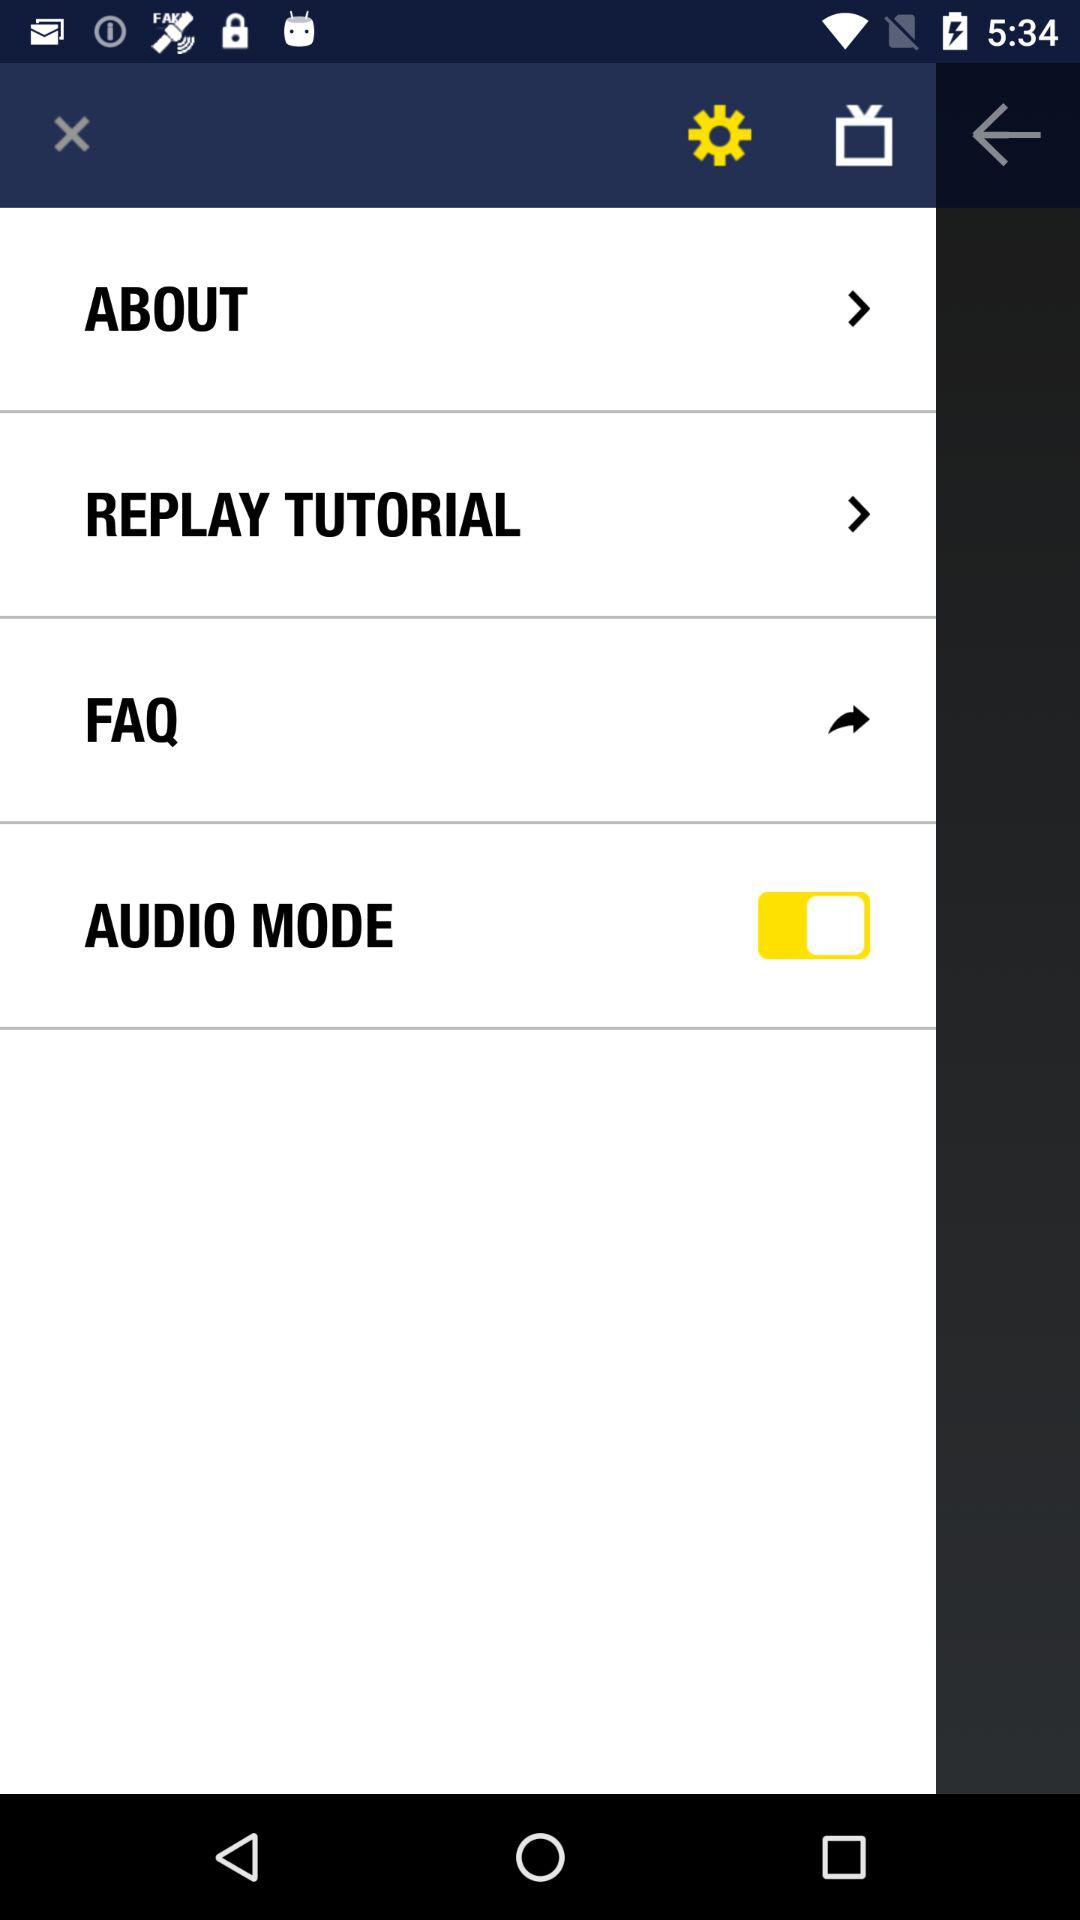What is the status of audio mode? The status is on. 